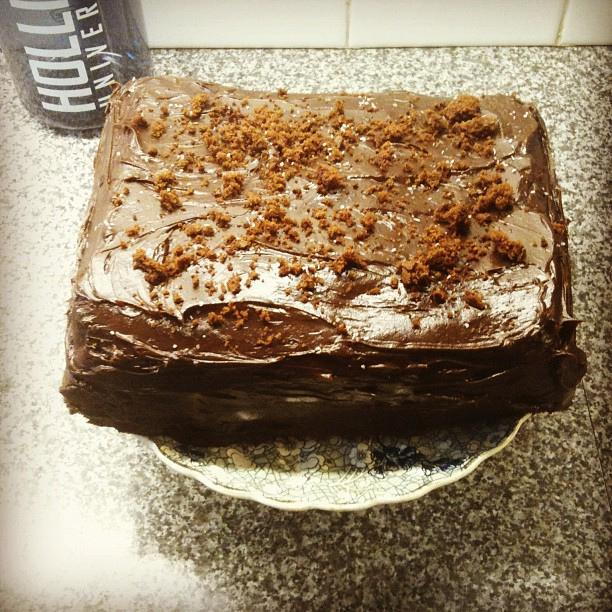What would this food item be ideal for?

Choices:
A) birthday
B) sweltering day
C) beach picnic
D) baseball stadium birthday 